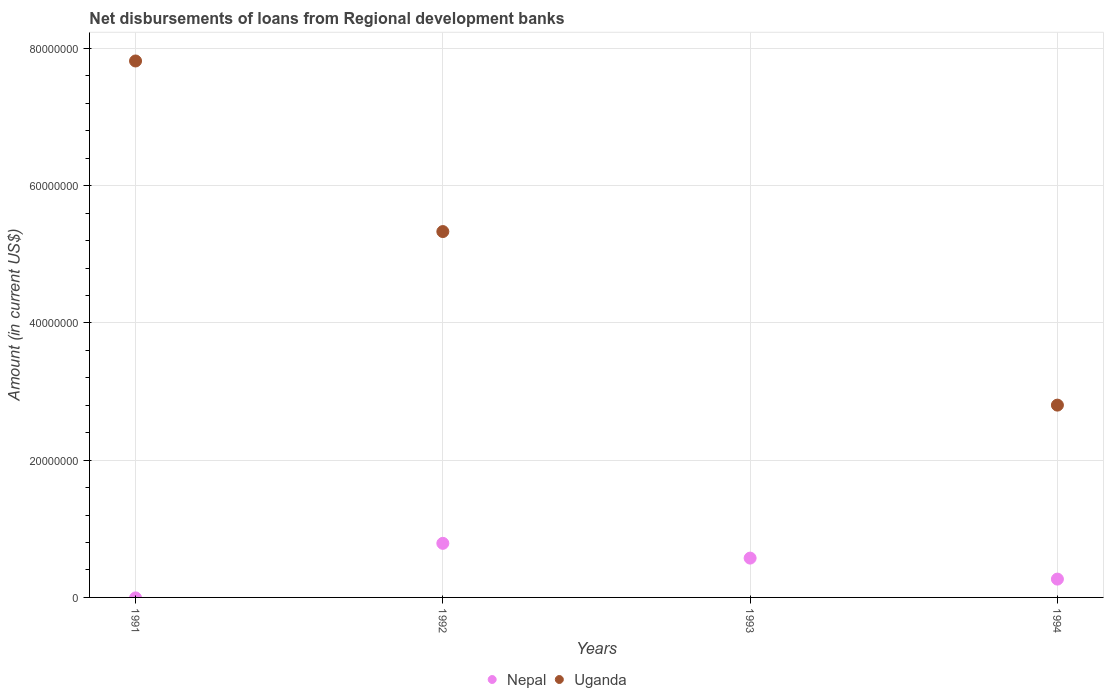Is the number of dotlines equal to the number of legend labels?
Provide a short and direct response. No. What is the amount of disbursements of loans from regional development banks in Uganda in 1992?
Provide a short and direct response. 5.33e+07. Across all years, what is the maximum amount of disbursements of loans from regional development banks in Uganda?
Offer a terse response. 7.82e+07. Across all years, what is the minimum amount of disbursements of loans from regional development banks in Nepal?
Ensure brevity in your answer.  0. What is the total amount of disbursements of loans from regional development banks in Nepal in the graph?
Make the answer very short. 1.63e+07. What is the difference between the amount of disbursements of loans from regional development banks in Uganda in 1992 and that in 1994?
Your response must be concise. 2.53e+07. What is the difference between the amount of disbursements of loans from regional development banks in Nepal in 1992 and the amount of disbursements of loans from regional development banks in Uganda in 1994?
Make the answer very short. -2.01e+07. What is the average amount of disbursements of loans from regional development banks in Nepal per year?
Your response must be concise. 4.07e+06. In the year 1992, what is the difference between the amount of disbursements of loans from regional development banks in Nepal and amount of disbursements of loans from regional development banks in Uganda?
Ensure brevity in your answer.  -4.54e+07. What is the ratio of the amount of disbursements of loans from regional development banks in Uganda in 1991 to that in 1992?
Offer a terse response. 1.47. Is the amount of disbursements of loans from regional development banks in Uganda in 1992 less than that in 1994?
Offer a terse response. No. Is the difference between the amount of disbursements of loans from regional development banks in Nepal in 1992 and 1994 greater than the difference between the amount of disbursements of loans from regional development banks in Uganda in 1992 and 1994?
Offer a very short reply. No. What is the difference between the highest and the second highest amount of disbursements of loans from regional development banks in Uganda?
Your answer should be very brief. 2.49e+07. What is the difference between the highest and the lowest amount of disbursements of loans from regional development banks in Uganda?
Offer a very short reply. 7.82e+07. In how many years, is the amount of disbursements of loans from regional development banks in Uganda greater than the average amount of disbursements of loans from regional development banks in Uganda taken over all years?
Offer a very short reply. 2. Is the sum of the amount of disbursements of loans from regional development banks in Nepal in 1993 and 1994 greater than the maximum amount of disbursements of loans from regional development banks in Uganda across all years?
Offer a very short reply. No. Is the amount of disbursements of loans from regional development banks in Uganda strictly greater than the amount of disbursements of loans from regional development banks in Nepal over the years?
Make the answer very short. No. How many dotlines are there?
Your answer should be very brief. 2. How many years are there in the graph?
Offer a terse response. 4. What is the difference between two consecutive major ticks on the Y-axis?
Ensure brevity in your answer.  2.00e+07. Does the graph contain any zero values?
Ensure brevity in your answer.  Yes. Does the graph contain grids?
Your answer should be very brief. Yes. How many legend labels are there?
Your answer should be compact. 2. What is the title of the graph?
Provide a short and direct response. Net disbursements of loans from Regional development banks. Does "Rwanda" appear as one of the legend labels in the graph?
Offer a terse response. No. What is the Amount (in current US$) in Uganda in 1991?
Give a very brief answer. 7.82e+07. What is the Amount (in current US$) in Nepal in 1992?
Your response must be concise. 7.88e+06. What is the Amount (in current US$) in Uganda in 1992?
Your answer should be very brief. 5.33e+07. What is the Amount (in current US$) in Nepal in 1993?
Keep it short and to the point. 5.73e+06. What is the Amount (in current US$) in Uganda in 1993?
Provide a short and direct response. 0. What is the Amount (in current US$) of Nepal in 1994?
Your answer should be compact. 2.67e+06. What is the Amount (in current US$) in Uganda in 1994?
Keep it short and to the point. 2.80e+07. Across all years, what is the maximum Amount (in current US$) in Nepal?
Ensure brevity in your answer.  7.88e+06. Across all years, what is the maximum Amount (in current US$) of Uganda?
Your answer should be compact. 7.82e+07. Across all years, what is the minimum Amount (in current US$) of Nepal?
Your answer should be very brief. 0. Across all years, what is the minimum Amount (in current US$) of Uganda?
Offer a terse response. 0. What is the total Amount (in current US$) of Nepal in the graph?
Provide a succinct answer. 1.63e+07. What is the total Amount (in current US$) in Uganda in the graph?
Give a very brief answer. 1.60e+08. What is the difference between the Amount (in current US$) in Uganda in 1991 and that in 1992?
Offer a terse response. 2.49e+07. What is the difference between the Amount (in current US$) in Uganda in 1991 and that in 1994?
Ensure brevity in your answer.  5.01e+07. What is the difference between the Amount (in current US$) in Nepal in 1992 and that in 1993?
Offer a very short reply. 2.15e+06. What is the difference between the Amount (in current US$) of Nepal in 1992 and that in 1994?
Provide a short and direct response. 5.21e+06. What is the difference between the Amount (in current US$) of Uganda in 1992 and that in 1994?
Provide a short and direct response. 2.53e+07. What is the difference between the Amount (in current US$) of Nepal in 1993 and that in 1994?
Your answer should be compact. 3.06e+06. What is the difference between the Amount (in current US$) in Nepal in 1992 and the Amount (in current US$) in Uganda in 1994?
Ensure brevity in your answer.  -2.01e+07. What is the difference between the Amount (in current US$) in Nepal in 1993 and the Amount (in current US$) in Uganda in 1994?
Your response must be concise. -2.23e+07. What is the average Amount (in current US$) in Nepal per year?
Your response must be concise. 4.07e+06. What is the average Amount (in current US$) in Uganda per year?
Keep it short and to the point. 3.99e+07. In the year 1992, what is the difference between the Amount (in current US$) in Nepal and Amount (in current US$) in Uganda?
Offer a very short reply. -4.54e+07. In the year 1994, what is the difference between the Amount (in current US$) in Nepal and Amount (in current US$) in Uganda?
Provide a succinct answer. -2.54e+07. What is the ratio of the Amount (in current US$) of Uganda in 1991 to that in 1992?
Provide a short and direct response. 1.47. What is the ratio of the Amount (in current US$) of Uganda in 1991 to that in 1994?
Give a very brief answer. 2.79. What is the ratio of the Amount (in current US$) in Nepal in 1992 to that in 1993?
Your answer should be very brief. 1.38. What is the ratio of the Amount (in current US$) of Nepal in 1992 to that in 1994?
Ensure brevity in your answer.  2.95. What is the ratio of the Amount (in current US$) of Uganda in 1992 to that in 1994?
Offer a terse response. 1.9. What is the ratio of the Amount (in current US$) in Nepal in 1993 to that in 1994?
Your answer should be compact. 2.15. What is the difference between the highest and the second highest Amount (in current US$) of Nepal?
Provide a short and direct response. 2.15e+06. What is the difference between the highest and the second highest Amount (in current US$) in Uganda?
Your answer should be very brief. 2.49e+07. What is the difference between the highest and the lowest Amount (in current US$) of Nepal?
Your answer should be very brief. 7.88e+06. What is the difference between the highest and the lowest Amount (in current US$) in Uganda?
Give a very brief answer. 7.82e+07. 